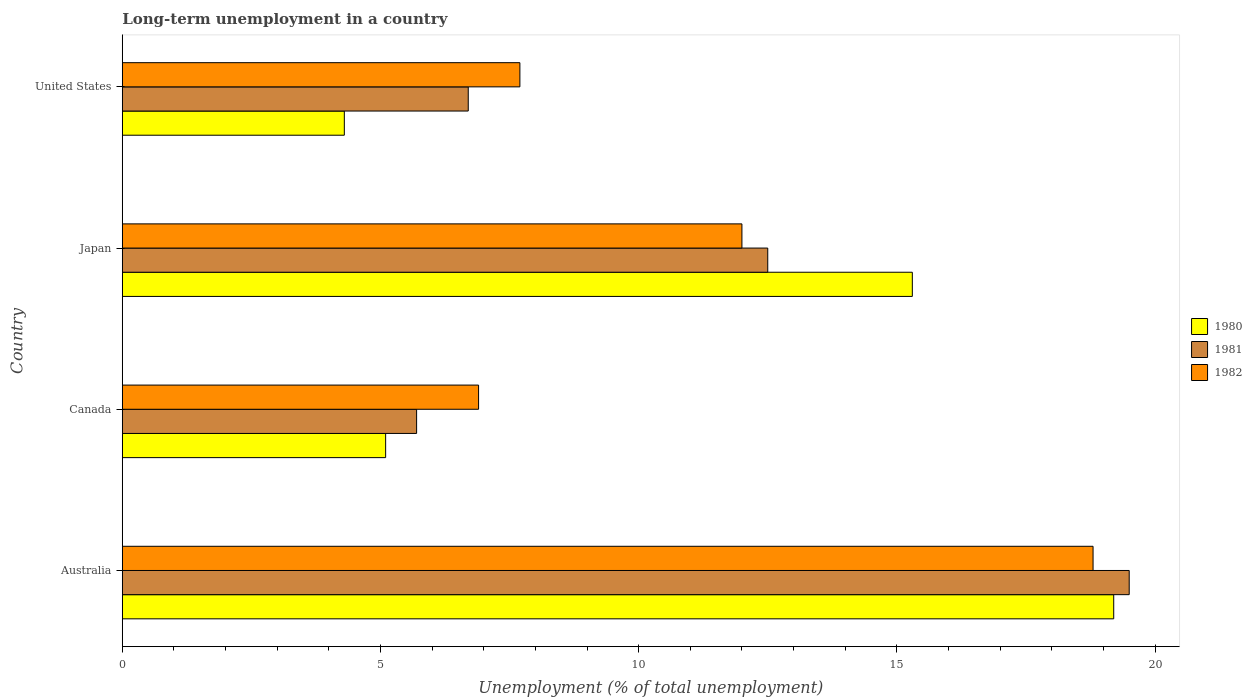How many groups of bars are there?
Offer a very short reply. 4. How many bars are there on the 4th tick from the top?
Provide a short and direct response. 3. In how many cases, is the number of bars for a given country not equal to the number of legend labels?
Provide a short and direct response. 0. Across all countries, what is the maximum percentage of long-term unemployed population in 1982?
Make the answer very short. 18.8. Across all countries, what is the minimum percentage of long-term unemployed population in 1981?
Provide a short and direct response. 5.7. In which country was the percentage of long-term unemployed population in 1982 maximum?
Ensure brevity in your answer.  Australia. What is the total percentage of long-term unemployed population in 1982 in the graph?
Keep it short and to the point. 45.4. What is the difference between the percentage of long-term unemployed population in 1982 in Japan and that in United States?
Your answer should be compact. 4.3. What is the difference between the percentage of long-term unemployed population in 1980 in Japan and the percentage of long-term unemployed population in 1981 in United States?
Your response must be concise. 8.6. What is the average percentage of long-term unemployed population in 1980 per country?
Ensure brevity in your answer.  10.98. What is the difference between the percentage of long-term unemployed population in 1982 and percentage of long-term unemployed population in 1980 in Canada?
Keep it short and to the point. 1.8. What is the ratio of the percentage of long-term unemployed population in 1980 in Canada to that in Japan?
Ensure brevity in your answer.  0.33. Is the difference between the percentage of long-term unemployed population in 1982 in Canada and United States greater than the difference between the percentage of long-term unemployed population in 1980 in Canada and United States?
Offer a terse response. No. What is the difference between the highest and the lowest percentage of long-term unemployed population in 1982?
Make the answer very short. 11.9. In how many countries, is the percentage of long-term unemployed population in 1981 greater than the average percentage of long-term unemployed population in 1981 taken over all countries?
Make the answer very short. 2. Is the sum of the percentage of long-term unemployed population in 1981 in Canada and United States greater than the maximum percentage of long-term unemployed population in 1980 across all countries?
Provide a short and direct response. No. What does the 1st bar from the bottom in Australia represents?
Offer a very short reply. 1980. Are all the bars in the graph horizontal?
Your answer should be compact. Yes. Does the graph contain grids?
Your response must be concise. No. Where does the legend appear in the graph?
Your answer should be very brief. Center right. How are the legend labels stacked?
Your answer should be compact. Vertical. What is the title of the graph?
Your response must be concise. Long-term unemployment in a country. What is the label or title of the X-axis?
Provide a succinct answer. Unemployment (% of total unemployment). What is the label or title of the Y-axis?
Keep it short and to the point. Country. What is the Unemployment (% of total unemployment) in 1980 in Australia?
Ensure brevity in your answer.  19.2. What is the Unemployment (% of total unemployment) of 1981 in Australia?
Keep it short and to the point. 19.5. What is the Unemployment (% of total unemployment) in 1982 in Australia?
Offer a very short reply. 18.8. What is the Unemployment (% of total unemployment) of 1980 in Canada?
Offer a very short reply. 5.1. What is the Unemployment (% of total unemployment) in 1981 in Canada?
Your answer should be compact. 5.7. What is the Unemployment (% of total unemployment) in 1982 in Canada?
Make the answer very short. 6.9. What is the Unemployment (% of total unemployment) in 1980 in Japan?
Give a very brief answer. 15.3. What is the Unemployment (% of total unemployment) of 1980 in United States?
Your response must be concise. 4.3. What is the Unemployment (% of total unemployment) in 1981 in United States?
Keep it short and to the point. 6.7. What is the Unemployment (% of total unemployment) of 1982 in United States?
Provide a short and direct response. 7.7. Across all countries, what is the maximum Unemployment (% of total unemployment) of 1980?
Offer a very short reply. 19.2. Across all countries, what is the maximum Unemployment (% of total unemployment) in 1981?
Offer a terse response. 19.5. Across all countries, what is the maximum Unemployment (% of total unemployment) of 1982?
Ensure brevity in your answer.  18.8. Across all countries, what is the minimum Unemployment (% of total unemployment) in 1980?
Your answer should be compact. 4.3. Across all countries, what is the minimum Unemployment (% of total unemployment) of 1981?
Your answer should be very brief. 5.7. Across all countries, what is the minimum Unemployment (% of total unemployment) in 1982?
Your response must be concise. 6.9. What is the total Unemployment (% of total unemployment) of 1980 in the graph?
Your answer should be very brief. 43.9. What is the total Unemployment (% of total unemployment) in 1981 in the graph?
Your response must be concise. 44.4. What is the total Unemployment (% of total unemployment) of 1982 in the graph?
Provide a succinct answer. 45.4. What is the difference between the Unemployment (% of total unemployment) in 1980 in Australia and that in Canada?
Your answer should be very brief. 14.1. What is the difference between the Unemployment (% of total unemployment) in 1982 in Australia and that in Canada?
Your answer should be compact. 11.9. What is the difference between the Unemployment (% of total unemployment) of 1980 in Australia and that in Japan?
Your answer should be compact. 3.9. What is the difference between the Unemployment (% of total unemployment) in 1981 in Australia and that in Japan?
Give a very brief answer. 7. What is the difference between the Unemployment (% of total unemployment) of 1982 in Australia and that in Japan?
Offer a very short reply. 6.8. What is the difference between the Unemployment (% of total unemployment) in 1980 in Australia and that in United States?
Offer a terse response. 14.9. What is the difference between the Unemployment (% of total unemployment) in 1981 in Australia and that in United States?
Your answer should be compact. 12.8. What is the difference between the Unemployment (% of total unemployment) of 1980 in Canada and that in Japan?
Provide a succinct answer. -10.2. What is the difference between the Unemployment (% of total unemployment) of 1982 in Canada and that in Japan?
Offer a very short reply. -5.1. What is the difference between the Unemployment (% of total unemployment) of 1982 in Japan and that in United States?
Make the answer very short. 4.3. What is the difference between the Unemployment (% of total unemployment) in 1980 in Australia and the Unemployment (% of total unemployment) in 1981 in Japan?
Ensure brevity in your answer.  6.7. What is the difference between the Unemployment (% of total unemployment) of 1980 in Australia and the Unemployment (% of total unemployment) of 1982 in Japan?
Make the answer very short. 7.2. What is the difference between the Unemployment (% of total unemployment) in 1980 in Australia and the Unemployment (% of total unemployment) in 1982 in United States?
Ensure brevity in your answer.  11.5. What is the difference between the Unemployment (% of total unemployment) of 1980 in Canada and the Unemployment (% of total unemployment) of 1981 in Japan?
Provide a succinct answer. -7.4. What is the difference between the Unemployment (% of total unemployment) of 1980 in Canada and the Unemployment (% of total unemployment) of 1981 in United States?
Your response must be concise. -1.6. What is the difference between the Unemployment (% of total unemployment) of 1981 in Canada and the Unemployment (% of total unemployment) of 1982 in United States?
Your answer should be compact. -2. What is the difference between the Unemployment (% of total unemployment) in 1980 in Japan and the Unemployment (% of total unemployment) in 1981 in United States?
Provide a succinct answer. 8.6. What is the difference between the Unemployment (% of total unemployment) of 1980 in Japan and the Unemployment (% of total unemployment) of 1982 in United States?
Provide a succinct answer. 7.6. What is the average Unemployment (% of total unemployment) in 1980 per country?
Offer a very short reply. 10.97. What is the average Unemployment (% of total unemployment) of 1982 per country?
Keep it short and to the point. 11.35. What is the difference between the Unemployment (% of total unemployment) of 1980 and Unemployment (% of total unemployment) of 1981 in Australia?
Provide a succinct answer. -0.3. What is the difference between the Unemployment (% of total unemployment) of 1980 and Unemployment (% of total unemployment) of 1982 in Australia?
Your response must be concise. 0.4. What is the difference between the Unemployment (% of total unemployment) in 1980 and Unemployment (% of total unemployment) in 1981 in Canada?
Offer a terse response. -0.6. What is the difference between the Unemployment (% of total unemployment) of 1980 and Unemployment (% of total unemployment) of 1982 in Canada?
Your response must be concise. -1.8. What is the difference between the Unemployment (% of total unemployment) in 1980 and Unemployment (% of total unemployment) in 1981 in Japan?
Your response must be concise. 2.8. What is the difference between the Unemployment (% of total unemployment) in 1980 and Unemployment (% of total unemployment) in 1981 in United States?
Offer a very short reply. -2.4. What is the ratio of the Unemployment (% of total unemployment) in 1980 in Australia to that in Canada?
Provide a short and direct response. 3.76. What is the ratio of the Unemployment (% of total unemployment) of 1981 in Australia to that in Canada?
Offer a terse response. 3.42. What is the ratio of the Unemployment (% of total unemployment) of 1982 in Australia to that in Canada?
Make the answer very short. 2.72. What is the ratio of the Unemployment (% of total unemployment) in 1980 in Australia to that in Japan?
Make the answer very short. 1.25. What is the ratio of the Unemployment (% of total unemployment) in 1981 in Australia to that in Japan?
Your answer should be compact. 1.56. What is the ratio of the Unemployment (% of total unemployment) in 1982 in Australia to that in Japan?
Make the answer very short. 1.57. What is the ratio of the Unemployment (% of total unemployment) of 1980 in Australia to that in United States?
Your answer should be compact. 4.47. What is the ratio of the Unemployment (% of total unemployment) in 1981 in Australia to that in United States?
Offer a terse response. 2.91. What is the ratio of the Unemployment (% of total unemployment) in 1982 in Australia to that in United States?
Offer a terse response. 2.44. What is the ratio of the Unemployment (% of total unemployment) of 1981 in Canada to that in Japan?
Offer a terse response. 0.46. What is the ratio of the Unemployment (% of total unemployment) in 1982 in Canada to that in Japan?
Offer a terse response. 0.57. What is the ratio of the Unemployment (% of total unemployment) of 1980 in Canada to that in United States?
Ensure brevity in your answer.  1.19. What is the ratio of the Unemployment (% of total unemployment) in 1981 in Canada to that in United States?
Make the answer very short. 0.85. What is the ratio of the Unemployment (% of total unemployment) in 1982 in Canada to that in United States?
Offer a very short reply. 0.9. What is the ratio of the Unemployment (% of total unemployment) of 1980 in Japan to that in United States?
Your answer should be compact. 3.56. What is the ratio of the Unemployment (% of total unemployment) in 1981 in Japan to that in United States?
Offer a terse response. 1.87. What is the ratio of the Unemployment (% of total unemployment) in 1982 in Japan to that in United States?
Make the answer very short. 1.56. What is the difference between the highest and the second highest Unemployment (% of total unemployment) in 1982?
Your response must be concise. 6.8. What is the difference between the highest and the lowest Unemployment (% of total unemployment) in 1980?
Make the answer very short. 14.9. What is the difference between the highest and the lowest Unemployment (% of total unemployment) in 1981?
Your answer should be compact. 13.8. 